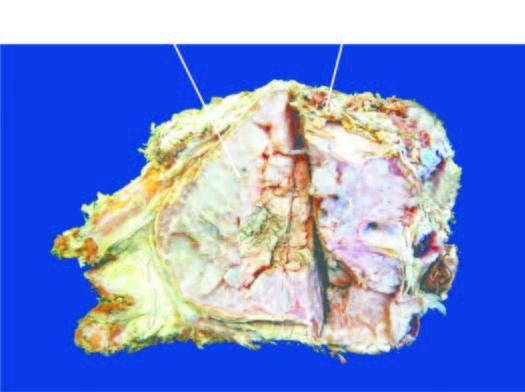what shows lobulated mass with bluish cartilaginous hue infiltrating the soft tissues?
Answer the question using a single word or phrase. Sectioned surface 